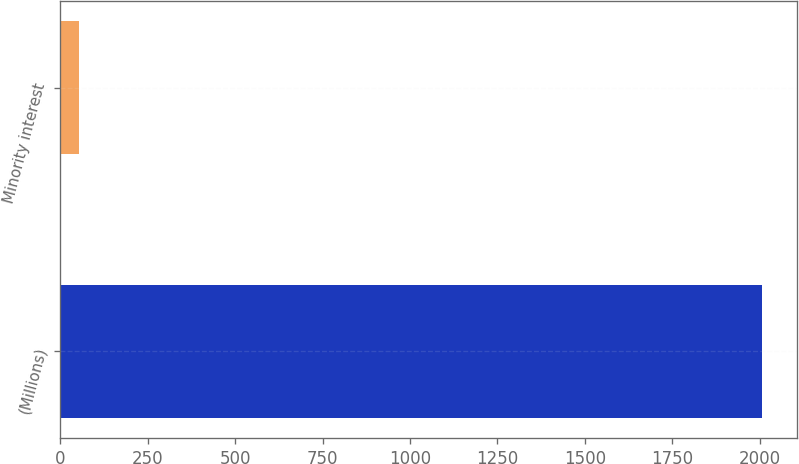Convert chart. <chart><loc_0><loc_0><loc_500><loc_500><bar_chart><fcel>(Millions)<fcel>Minority interest<nl><fcel>2005<fcel>55<nl></chart> 